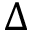Convert formula to latex. <formula><loc_0><loc_0><loc_500><loc_500>\Delta</formula> 